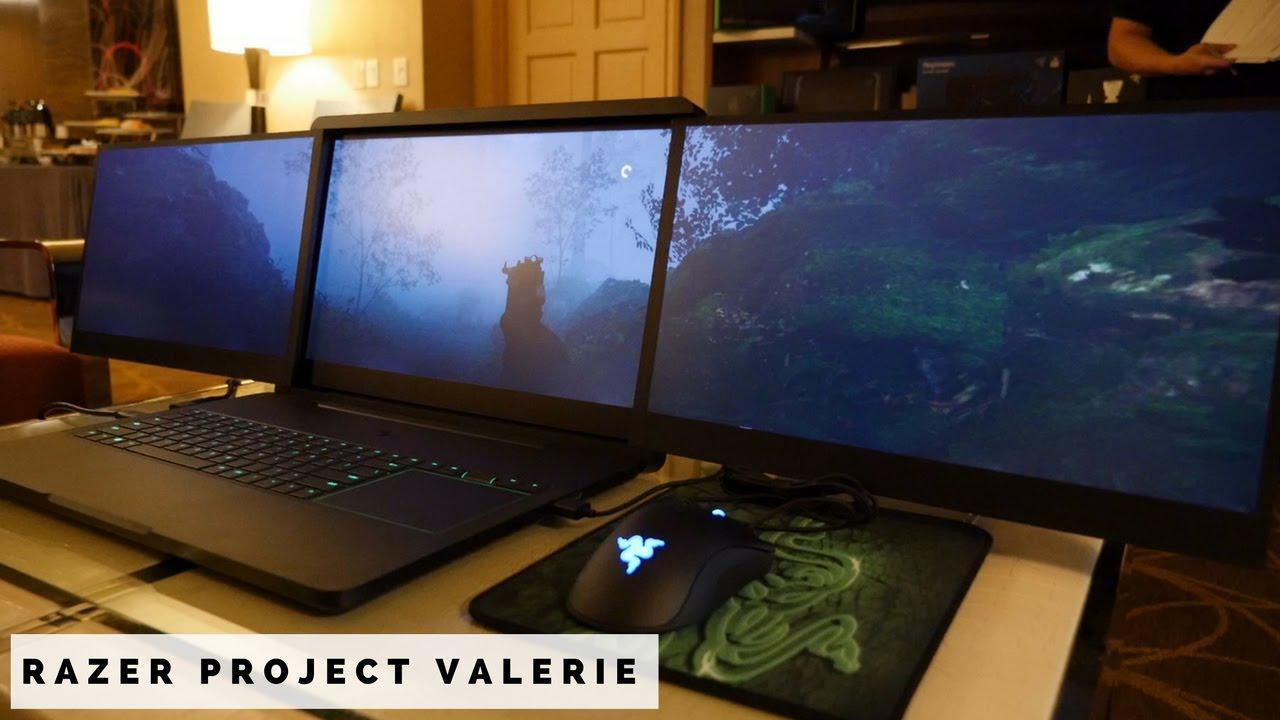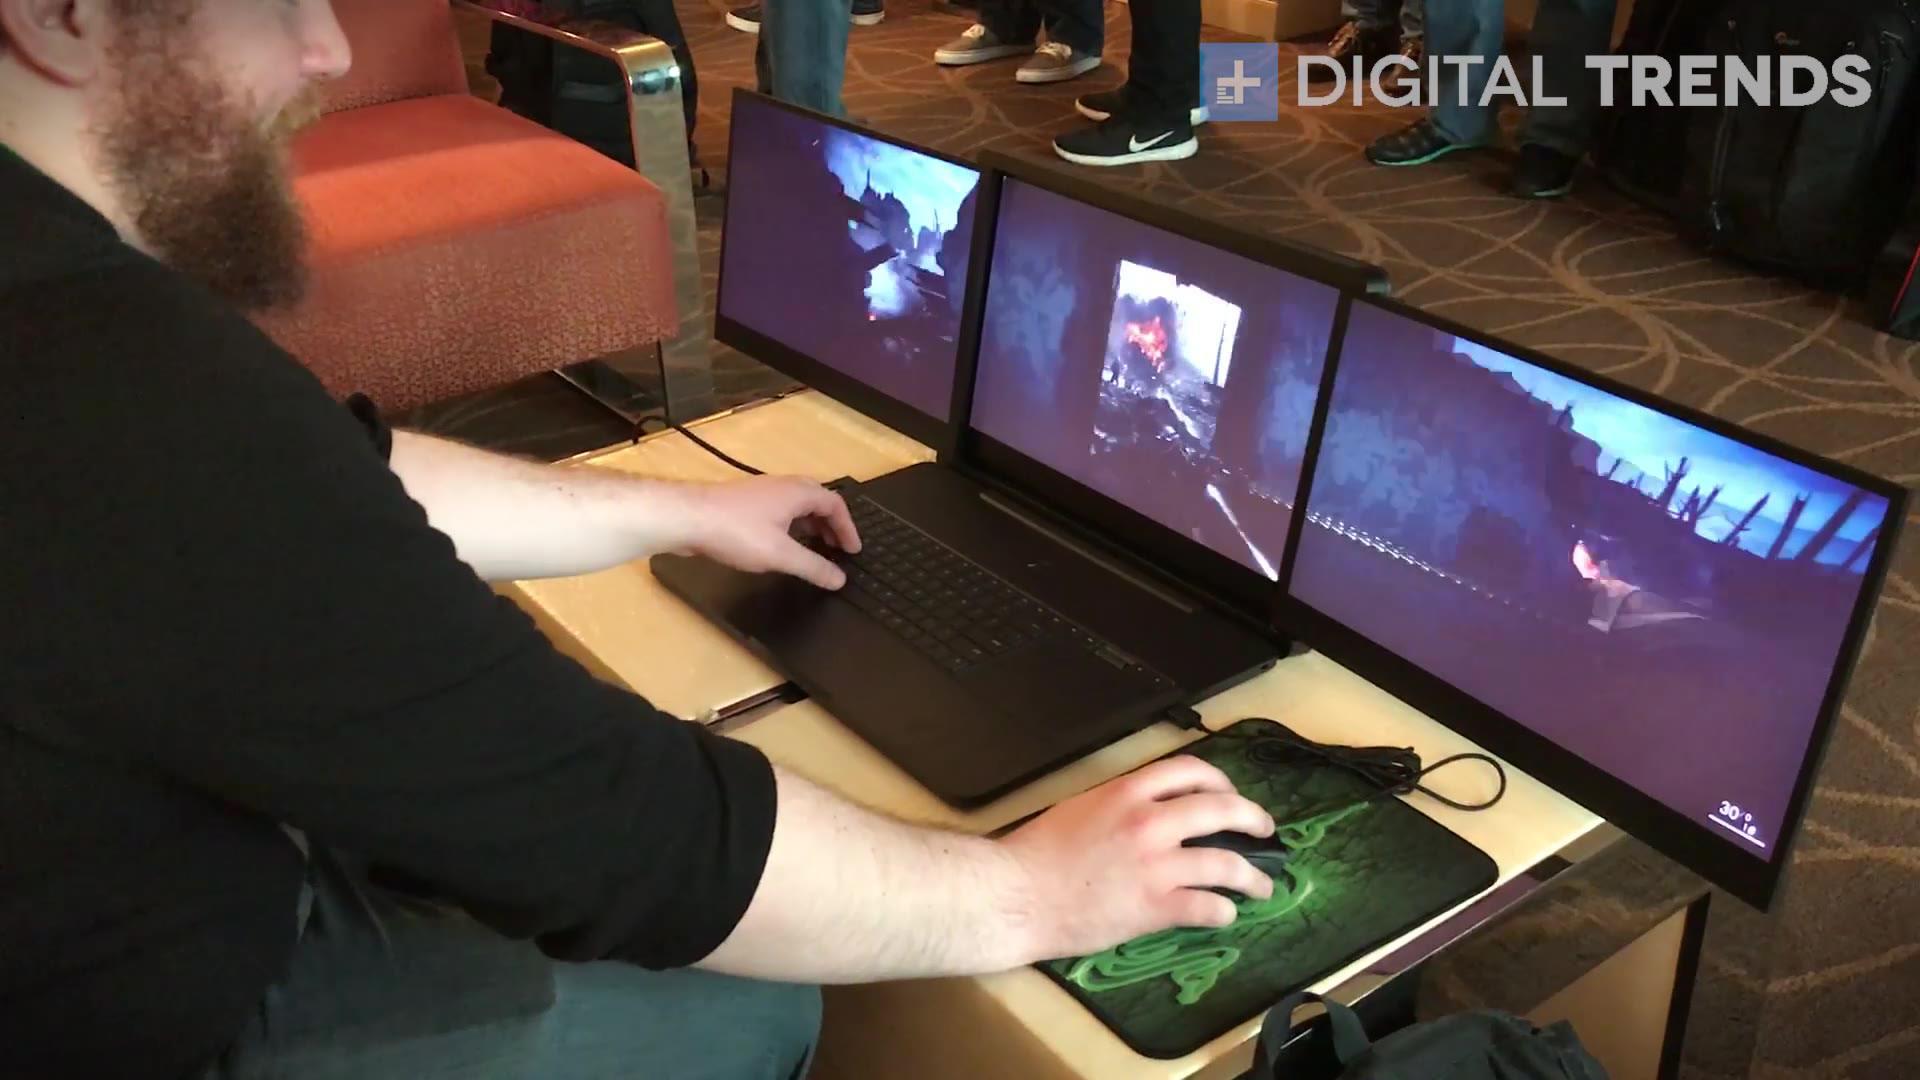The first image is the image on the left, the second image is the image on the right. For the images displayed, is the sentence "Each image shows a mostly head-on view of a triple-display laptop on a brownish desk, projecting a video game scene." factually correct? Answer yes or no. No. The first image is the image on the left, the second image is the image on the right. Considering the images on both sides, is "The computer mouse in one of the image has a purple triangle light on it." valid? Answer yes or no. No. 